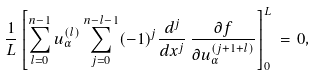Convert formula to latex. <formula><loc_0><loc_0><loc_500><loc_500>\frac { 1 } { L } \left [ \sum _ { l = 0 } ^ { n - 1 } u _ { \alpha } ^ { ( l ) } \sum _ { j = 0 } ^ { n - l - 1 } ( - 1 ) ^ { j } \frac { d ^ { j } } { d x ^ { j } } \, \frac { \partial f } { \partial u _ { \alpha } ^ { ( j + 1 + l ) } } \right ] _ { 0 } ^ { L } \, = \, 0 ,</formula> 